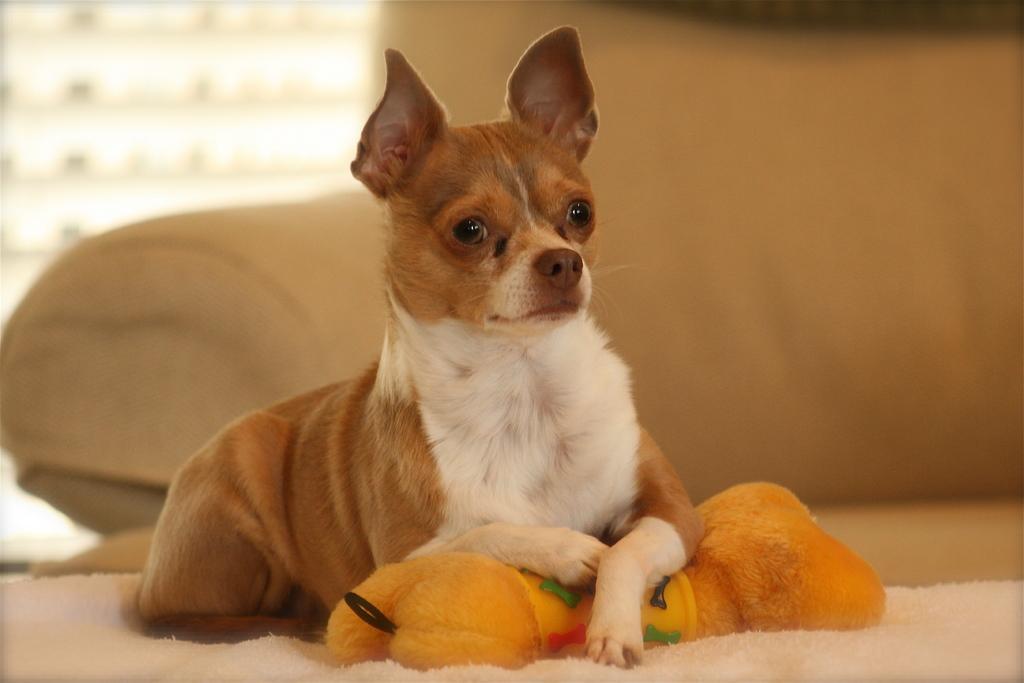How would you summarize this image in a sentence or two? In this picture we can see a dog sitting on a cloth and in the background we can see a sofa and it is blurry. 